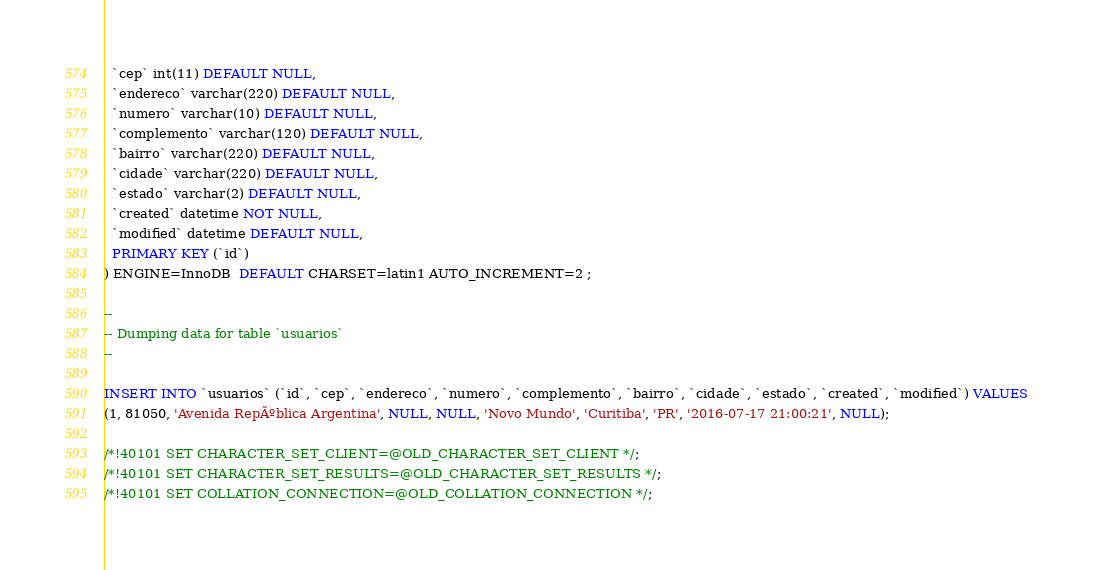Convert code to text. <code><loc_0><loc_0><loc_500><loc_500><_SQL_>  `cep` int(11) DEFAULT NULL,
  `endereco` varchar(220) DEFAULT NULL,
  `numero` varchar(10) DEFAULT NULL,
  `complemento` varchar(120) DEFAULT NULL,
  `bairro` varchar(220) DEFAULT NULL,
  `cidade` varchar(220) DEFAULT NULL,
  `estado` varchar(2) DEFAULT NULL,
  `created` datetime NOT NULL,
  `modified` datetime DEFAULT NULL,
  PRIMARY KEY (`id`)
) ENGINE=InnoDB  DEFAULT CHARSET=latin1 AUTO_INCREMENT=2 ;

--
-- Dumping data for table `usuarios`
--

INSERT INTO `usuarios` (`id`, `cep`, `endereco`, `numero`, `complemento`, `bairro`, `cidade`, `estado`, `created`, `modified`) VALUES
(1, 81050, 'Avenida RepÃºblica Argentina', NULL, NULL, 'Novo Mundo', 'Curitiba', 'PR', '2016-07-17 21:00:21', NULL);

/*!40101 SET CHARACTER_SET_CLIENT=@OLD_CHARACTER_SET_CLIENT */;
/*!40101 SET CHARACTER_SET_RESULTS=@OLD_CHARACTER_SET_RESULTS */;
/*!40101 SET COLLATION_CONNECTION=@OLD_COLLATION_CONNECTION */;
</code> 